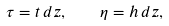Convert formula to latex. <formula><loc_0><loc_0><loc_500><loc_500>\tau = t \, d z , \quad \eta = h \, d z ,</formula> 